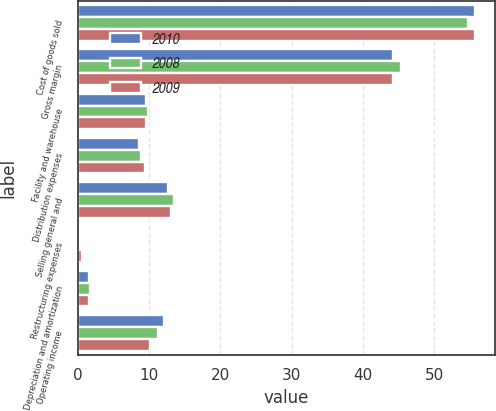Convert chart. <chart><loc_0><loc_0><loc_500><loc_500><stacked_bar_chart><ecel><fcel>Cost of goods sold<fcel>Gross margin<fcel>Facility and warehouse<fcel>Distribution expenses<fcel>Selling general and<fcel>Restructuring expenses<fcel>Depreciation and amortization<fcel>Operating income<nl><fcel>2010<fcel>55.7<fcel>44.3<fcel>9.5<fcel>8.6<fcel>12.6<fcel>0<fcel>1.5<fcel>12.1<nl><fcel>2008<fcel>54.7<fcel>45.3<fcel>9.8<fcel>8.9<fcel>13.5<fcel>0.1<fcel>1.7<fcel>11.3<nl><fcel>2009<fcel>55.8<fcel>44.2<fcel>9.5<fcel>9.4<fcel>13.1<fcel>0.5<fcel>1.6<fcel>10.1<nl></chart> 